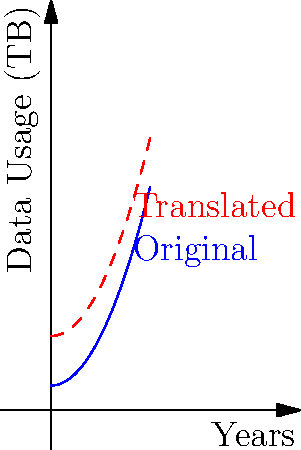The blue curve represents mobile data usage trends in Saudi Arabia over the past 4 years. If the trend continues but with an additional 2 TB increase each year due to 5G adoption, how would you describe the transformation of the graph? To answer this question, we need to analyze the transformation applied to the original graph:

1. The original graph (blue) represents the current mobile data usage trend.
2. The new graph (red, dashed) shows the projected trend with 5G adoption.
3. Comparing the two graphs, we can see that:
   a. The shape of the curve remains the same.
   b. The entire graph has moved upward.
   c. The vertical distance between the original and new graph is constant at 2 units (2 TB).

4. In transformational geometry, when a graph moves vertically without changing its shape, it's called a vertical translation.
5. The magnitude of the translation is 2 units upward, corresponding to the 2 TB increase each year.

Therefore, the transformation applied to the original graph is a vertical translation of 2 units upward, which can be represented mathematically as $f(x) \rightarrow f(x) + 2$.
Answer: Vertical translation by 2 units upward 